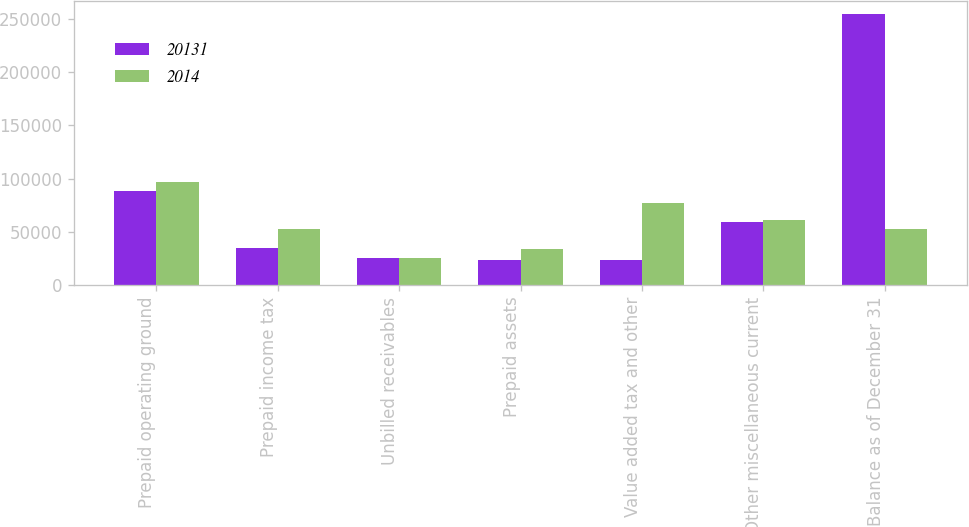<chart> <loc_0><loc_0><loc_500><loc_500><stacked_bar_chart><ecel><fcel>Prepaid operating ground<fcel>Prepaid income tax<fcel>Unbilled receivables<fcel>Prepaid assets<fcel>Value added tax and other<fcel>Other miscellaneous current<fcel>Balance as of December 31<nl><fcel>20131<fcel>88508<fcel>34512<fcel>25352<fcel>23848<fcel>23228<fcel>59174<fcel>254622<nl><fcel>2014<fcel>96881<fcel>52612<fcel>25412<fcel>34243<fcel>77016<fcel>61253<fcel>52612<nl></chart> 